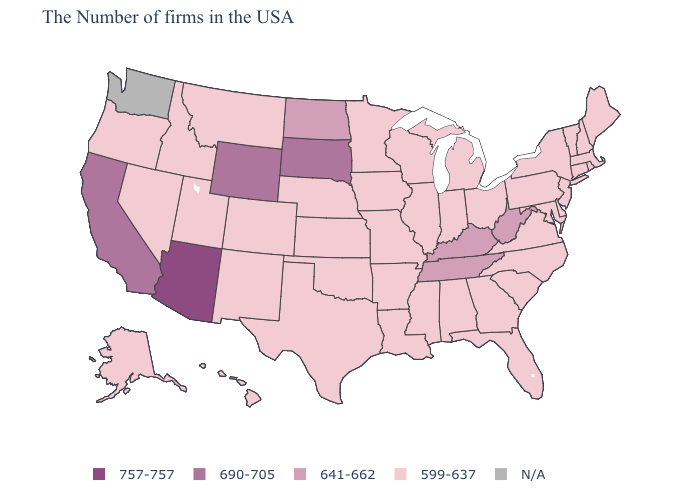Name the states that have a value in the range 757-757?
Write a very short answer. Arizona. Which states have the lowest value in the USA?
Concise answer only. Maine, Massachusetts, Rhode Island, New Hampshire, Vermont, Connecticut, New York, New Jersey, Delaware, Maryland, Pennsylvania, Virginia, North Carolina, South Carolina, Ohio, Florida, Georgia, Michigan, Indiana, Alabama, Wisconsin, Illinois, Mississippi, Louisiana, Missouri, Arkansas, Minnesota, Iowa, Kansas, Nebraska, Oklahoma, Texas, Colorado, New Mexico, Utah, Montana, Idaho, Nevada, Oregon, Alaska, Hawaii. What is the highest value in states that border Florida?
Quick response, please. 599-637. What is the value of Iowa?
Answer briefly. 599-637. Name the states that have a value in the range 641-662?
Concise answer only. West Virginia, Kentucky, Tennessee, North Dakota. Among the states that border Virginia , does Maryland have the highest value?
Concise answer only. No. What is the highest value in the South ?
Keep it brief. 641-662. What is the lowest value in states that border Iowa?
Write a very short answer. 599-637. Among the states that border Ohio , does Michigan have the highest value?
Concise answer only. No. How many symbols are there in the legend?
Answer briefly. 5. Among the states that border North Carolina , which have the highest value?
Write a very short answer. Tennessee. Does the map have missing data?
Concise answer only. Yes. Among the states that border Massachusetts , which have the lowest value?
Short answer required. Rhode Island, New Hampshire, Vermont, Connecticut, New York. Does the first symbol in the legend represent the smallest category?
Be succinct. No. 